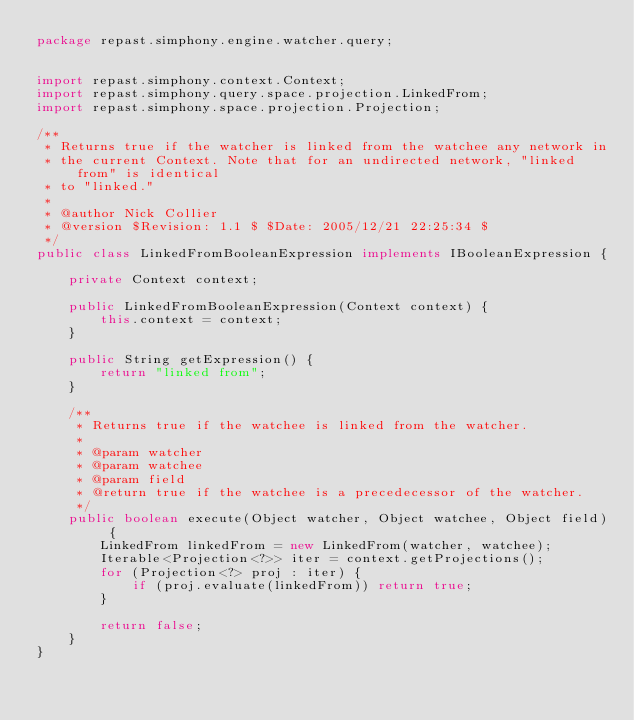Convert code to text. <code><loc_0><loc_0><loc_500><loc_500><_Java_>package repast.simphony.engine.watcher.query;


import repast.simphony.context.Context;
import repast.simphony.query.space.projection.LinkedFrom;
import repast.simphony.space.projection.Projection;

/**
 * Returns true if the watcher is linked from the watchee any network in
 * the current Context. Note that for an undirected network, "linked from" is identical
 * to "linked."
 *
 * @author Nick Collier
 * @version $Revision: 1.1 $ $Date: 2005/12/21 22:25:34 $
 */
public class LinkedFromBooleanExpression implements IBooleanExpression {

	private Context context;

	public LinkedFromBooleanExpression(Context context) {
		this.context = context;
	}

	public String getExpression() {
		return "linked from";
	}

	/**
	 * Returns true if the watchee is linked from the watcher.
	 *
	 * @param watcher
	 * @param watchee
	 * @param field
	 * @return true if the watchee is a precedecessor of the watcher.
	 */
	public boolean execute(Object watcher, Object watchee, Object field) {
		LinkedFrom linkedFrom = new LinkedFrom(watcher, watchee);
		Iterable<Projection<?>> iter = context.getProjections();
		for (Projection<?> proj : iter) {
			if (proj.evaluate(linkedFrom)) return true;
		}

		return false;
	}
}
</code> 